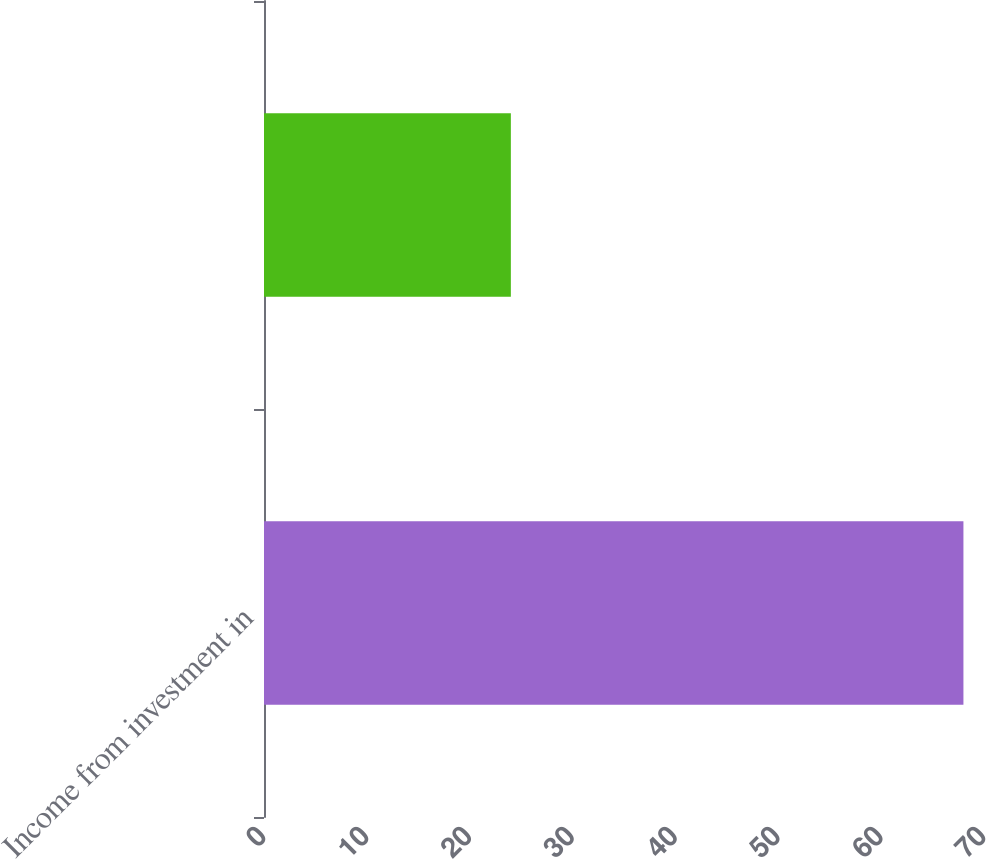Convert chart to OTSL. <chart><loc_0><loc_0><loc_500><loc_500><bar_chart><fcel>Income from investment in<fcel>Unnamed: 1<nl><fcel>68<fcel>24<nl></chart> 